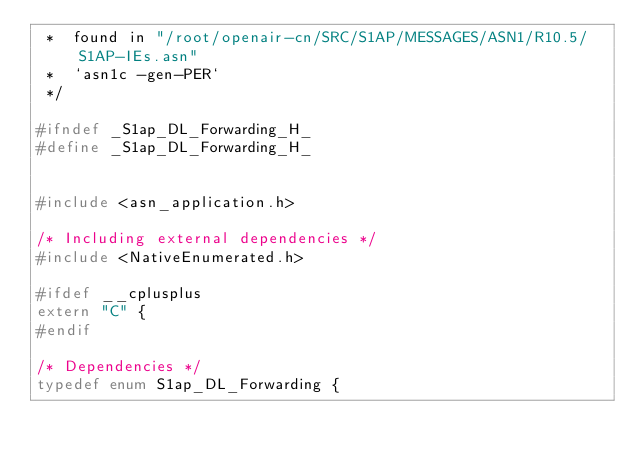<code> <loc_0><loc_0><loc_500><loc_500><_C_> * 	found in "/root/openair-cn/SRC/S1AP/MESSAGES/ASN1/R10.5/S1AP-IEs.asn"
 * 	`asn1c -gen-PER`
 */

#ifndef	_S1ap_DL_Forwarding_H_
#define	_S1ap_DL_Forwarding_H_


#include <asn_application.h>

/* Including external dependencies */
#include <NativeEnumerated.h>

#ifdef __cplusplus
extern "C" {
#endif

/* Dependencies */
typedef enum S1ap_DL_Forwarding {</code> 